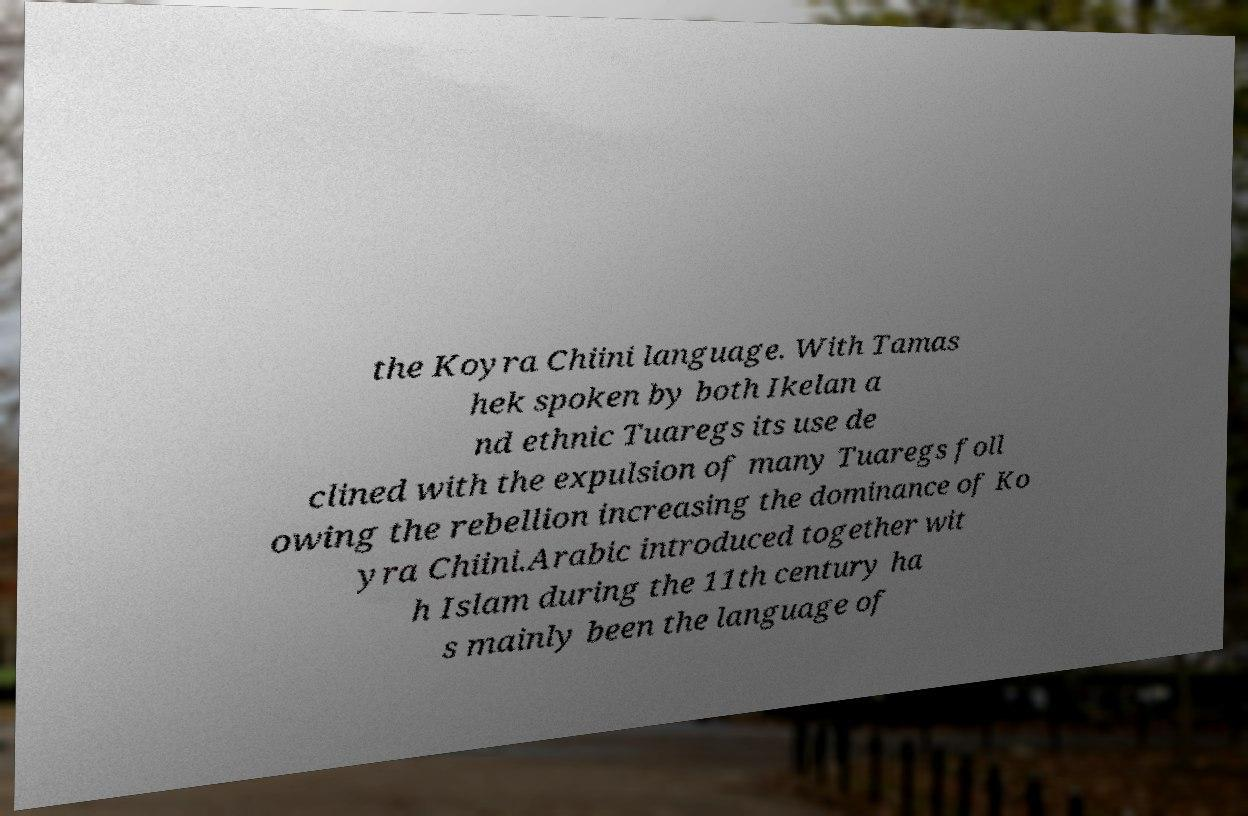For documentation purposes, I need the text within this image transcribed. Could you provide that? the Koyra Chiini language. With Tamas hek spoken by both Ikelan a nd ethnic Tuaregs its use de clined with the expulsion of many Tuaregs foll owing the rebellion increasing the dominance of Ko yra Chiini.Arabic introduced together wit h Islam during the 11th century ha s mainly been the language of 